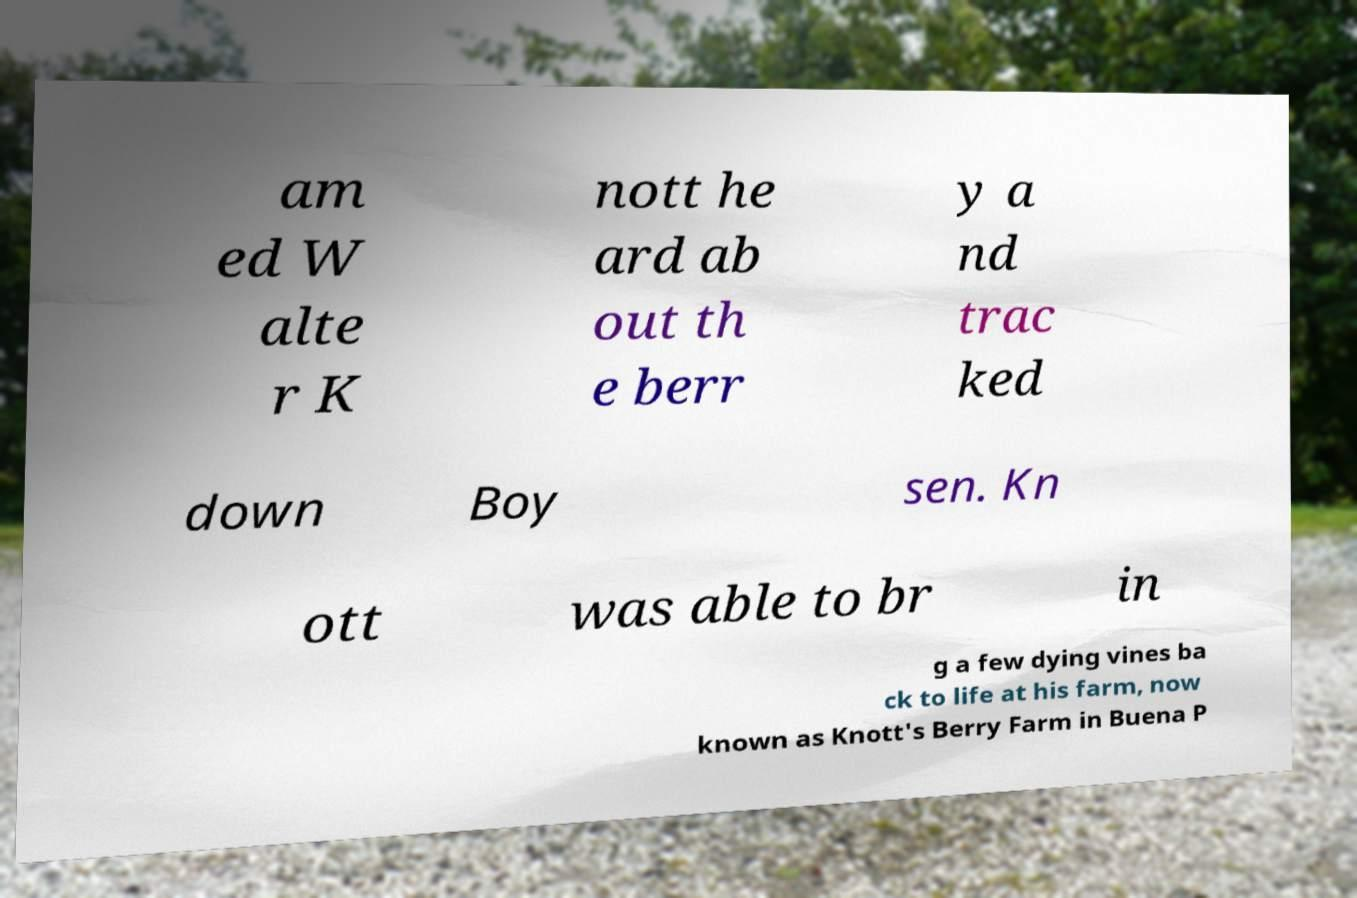Please identify and transcribe the text found in this image. am ed W alte r K nott he ard ab out th e berr y a nd trac ked down Boy sen. Kn ott was able to br in g a few dying vines ba ck to life at his farm, now known as Knott's Berry Farm in Buena P 